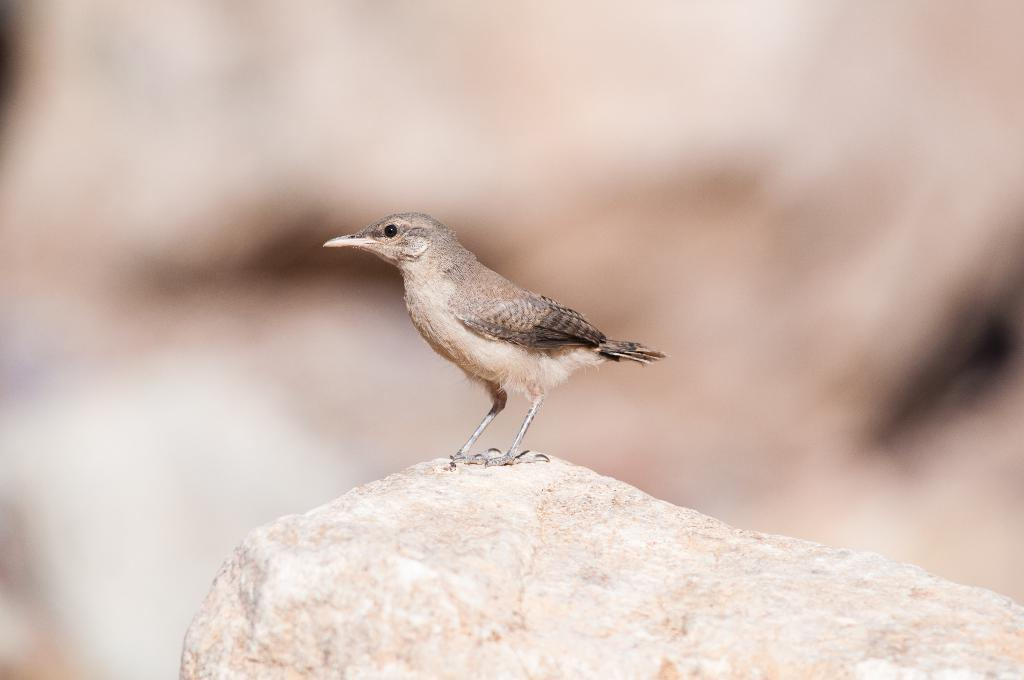What type of animal can be seen in the image? There is a bird in the image. Where is the bird located? The bird is on a rock. Can you describe the background of the image? The background of the image is blurred. What type of protest is happening in the background of the image? There is no protest visible in the image; the background is blurred. What type of pet is the bird in the image? The image does not indicate that the bird is a pet. 